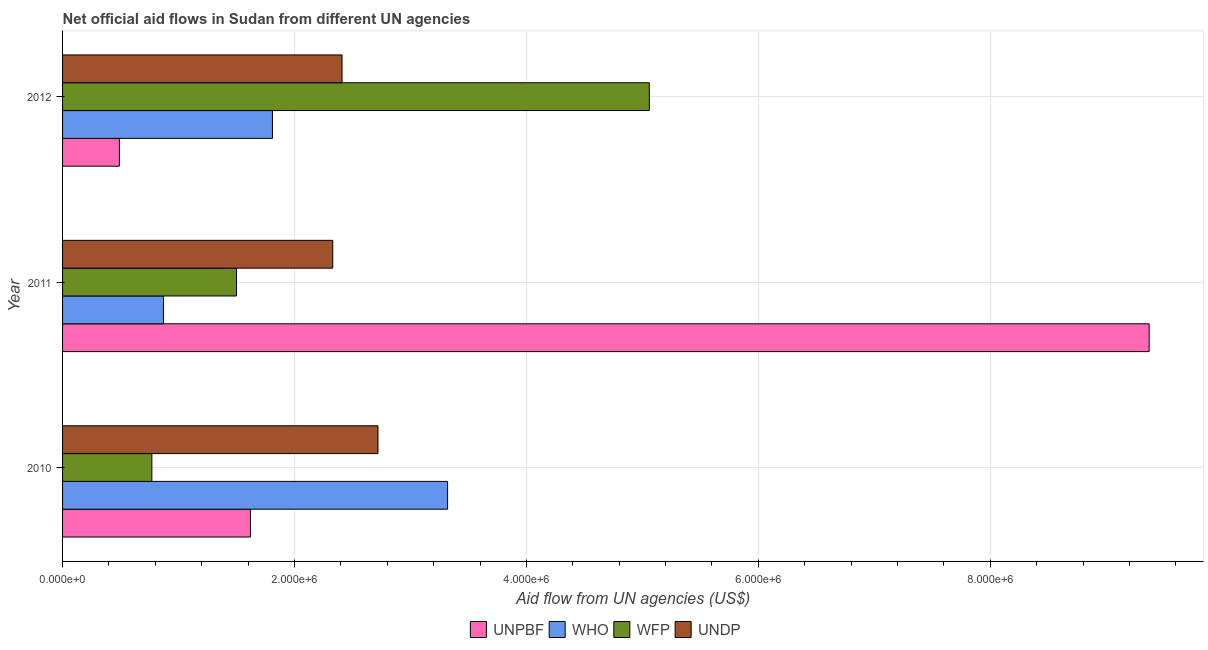How many bars are there on the 2nd tick from the top?
Offer a very short reply. 4. In how many cases, is the number of bars for a given year not equal to the number of legend labels?
Your answer should be compact. 0. What is the amount of aid given by undp in 2011?
Provide a short and direct response. 2.33e+06. Across all years, what is the maximum amount of aid given by undp?
Keep it short and to the point. 2.72e+06. Across all years, what is the minimum amount of aid given by undp?
Your answer should be compact. 2.33e+06. In which year was the amount of aid given by unpbf maximum?
Your answer should be compact. 2011. What is the total amount of aid given by who in the graph?
Ensure brevity in your answer.  6.00e+06. What is the difference between the amount of aid given by who in 2010 and that in 2011?
Offer a terse response. 2.45e+06. What is the difference between the amount of aid given by wfp in 2012 and the amount of aid given by undp in 2011?
Provide a succinct answer. 2.73e+06. What is the average amount of aid given by wfp per year?
Give a very brief answer. 2.44e+06. In the year 2010, what is the difference between the amount of aid given by who and amount of aid given by wfp?
Provide a succinct answer. 2.55e+06. What is the ratio of the amount of aid given by undp in 2010 to that in 2012?
Your answer should be compact. 1.13. What is the difference between the highest and the lowest amount of aid given by who?
Your answer should be very brief. 2.45e+06. Is the sum of the amount of aid given by undp in 2010 and 2011 greater than the maximum amount of aid given by unpbf across all years?
Ensure brevity in your answer.  No. What does the 3rd bar from the top in 2012 represents?
Make the answer very short. WHO. What does the 4th bar from the bottom in 2012 represents?
Your answer should be compact. UNDP. Is it the case that in every year, the sum of the amount of aid given by unpbf and amount of aid given by who is greater than the amount of aid given by wfp?
Your response must be concise. No. Are all the bars in the graph horizontal?
Provide a succinct answer. Yes. How many years are there in the graph?
Keep it short and to the point. 3. What is the difference between two consecutive major ticks on the X-axis?
Ensure brevity in your answer.  2.00e+06. Are the values on the major ticks of X-axis written in scientific E-notation?
Ensure brevity in your answer.  Yes. Does the graph contain any zero values?
Make the answer very short. No. Where does the legend appear in the graph?
Ensure brevity in your answer.  Bottom center. How are the legend labels stacked?
Make the answer very short. Horizontal. What is the title of the graph?
Give a very brief answer. Net official aid flows in Sudan from different UN agencies. What is the label or title of the X-axis?
Your answer should be compact. Aid flow from UN agencies (US$). What is the label or title of the Y-axis?
Provide a succinct answer. Year. What is the Aid flow from UN agencies (US$) of UNPBF in 2010?
Provide a succinct answer. 1.62e+06. What is the Aid flow from UN agencies (US$) of WHO in 2010?
Your response must be concise. 3.32e+06. What is the Aid flow from UN agencies (US$) in WFP in 2010?
Your response must be concise. 7.70e+05. What is the Aid flow from UN agencies (US$) of UNDP in 2010?
Your response must be concise. 2.72e+06. What is the Aid flow from UN agencies (US$) of UNPBF in 2011?
Provide a succinct answer. 9.37e+06. What is the Aid flow from UN agencies (US$) in WHO in 2011?
Provide a succinct answer. 8.70e+05. What is the Aid flow from UN agencies (US$) in WFP in 2011?
Make the answer very short. 1.50e+06. What is the Aid flow from UN agencies (US$) in UNDP in 2011?
Your answer should be very brief. 2.33e+06. What is the Aid flow from UN agencies (US$) in WHO in 2012?
Make the answer very short. 1.81e+06. What is the Aid flow from UN agencies (US$) in WFP in 2012?
Your answer should be very brief. 5.06e+06. What is the Aid flow from UN agencies (US$) of UNDP in 2012?
Your answer should be compact. 2.41e+06. Across all years, what is the maximum Aid flow from UN agencies (US$) of UNPBF?
Provide a short and direct response. 9.37e+06. Across all years, what is the maximum Aid flow from UN agencies (US$) of WHO?
Keep it short and to the point. 3.32e+06. Across all years, what is the maximum Aid flow from UN agencies (US$) of WFP?
Provide a short and direct response. 5.06e+06. Across all years, what is the maximum Aid flow from UN agencies (US$) in UNDP?
Offer a terse response. 2.72e+06. Across all years, what is the minimum Aid flow from UN agencies (US$) of UNPBF?
Offer a terse response. 4.90e+05. Across all years, what is the minimum Aid flow from UN agencies (US$) of WHO?
Make the answer very short. 8.70e+05. Across all years, what is the minimum Aid flow from UN agencies (US$) of WFP?
Your response must be concise. 7.70e+05. Across all years, what is the minimum Aid flow from UN agencies (US$) of UNDP?
Your answer should be very brief. 2.33e+06. What is the total Aid flow from UN agencies (US$) in UNPBF in the graph?
Your response must be concise. 1.15e+07. What is the total Aid flow from UN agencies (US$) in WHO in the graph?
Keep it short and to the point. 6.00e+06. What is the total Aid flow from UN agencies (US$) of WFP in the graph?
Offer a terse response. 7.33e+06. What is the total Aid flow from UN agencies (US$) in UNDP in the graph?
Provide a short and direct response. 7.46e+06. What is the difference between the Aid flow from UN agencies (US$) in UNPBF in 2010 and that in 2011?
Give a very brief answer. -7.75e+06. What is the difference between the Aid flow from UN agencies (US$) of WHO in 2010 and that in 2011?
Your response must be concise. 2.45e+06. What is the difference between the Aid flow from UN agencies (US$) in WFP in 2010 and that in 2011?
Ensure brevity in your answer.  -7.30e+05. What is the difference between the Aid flow from UN agencies (US$) of UNDP in 2010 and that in 2011?
Give a very brief answer. 3.90e+05. What is the difference between the Aid flow from UN agencies (US$) in UNPBF in 2010 and that in 2012?
Your response must be concise. 1.13e+06. What is the difference between the Aid flow from UN agencies (US$) in WHO in 2010 and that in 2012?
Your response must be concise. 1.51e+06. What is the difference between the Aid flow from UN agencies (US$) in WFP in 2010 and that in 2012?
Make the answer very short. -4.29e+06. What is the difference between the Aid flow from UN agencies (US$) in UNPBF in 2011 and that in 2012?
Your answer should be compact. 8.88e+06. What is the difference between the Aid flow from UN agencies (US$) of WHO in 2011 and that in 2012?
Make the answer very short. -9.40e+05. What is the difference between the Aid flow from UN agencies (US$) of WFP in 2011 and that in 2012?
Your answer should be compact. -3.56e+06. What is the difference between the Aid flow from UN agencies (US$) in UNDP in 2011 and that in 2012?
Provide a short and direct response. -8.00e+04. What is the difference between the Aid flow from UN agencies (US$) of UNPBF in 2010 and the Aid flow from UN agencies (US$) of WHO in 2011?
Offer a terse response. 7.50e+05. What is the difference between the Aid flow from UN agencies (US$) in UNPBF in 2010 and the Aid flow from UN agencies (US$) in UNDP in 2011?
Give a very brief answer. -7.10e+05. What is the difference between the Aid flow from UN agencies (US$) of WHO in 2010 and the Aid flow from UN agencies (US$) of WFP in 2011?
Make the answer very short. 1.82e+06. What is the difference between the Aid flow from UN agencies (US$) of WHO in 2010 and the Aid flow from UN agencies (US$) of UNDP in 2011?
Make the answer very short. 9.90e+05. What is the difference between the Aid flow from UN agencies (US$) in WFP in 2010 and the Aid flow from UN agencies (US$) in UNDP in 2011?
Your answer should be compact. -1.56e+06. What is the difference between the Aid flow from UN agencies (US$) in UNPBF in 2010 and the Aid flow from UN agencies (US$) in WFP in 2012?
Offer a terse response. -3.44e+06. What is the difference between the Aid flow from UN agencies (US$) in UNPBF in 2010 and the Aid flow from UN agencies (US$) in UNDP in 2012?
Your answer should be very brief. -7.90e+05. What is the difference between the Aid flow from UN agencies (US$) in WHO in 2010 and the Aid flow from UN agencies (US$) in WFP in 2012?
Your response must be concise. -1.74e+06. What is the difference between the Aid flow from UN agencies (US$) in WHO in 2010 and the Aid flow from UN agencies (US$) in UNDP in 2012?
Your response must be concise. 9.10e+05. What is the difference between the Aid flow from UN agencies (US$) in WFP in 2010 and the Aid flow from UN agencies (US$) in UNDP in 2012?
Ensure brevity in your answer.  -1.64e+06. What is the difference between the Aid flow from UN agencies (US$) in UNPBF in 2011 and the Aid flow from UN agencies (US$) in WHO in 2012?
Your answer should be compact. 7.56e+06. What is the difference between the Aid flow from UN agencies (US$) of UNPBF in 2011 and the Aid flow from UN agencies (US$) of WFP in 2012?
Provide a short and direct response. 4.31e+06. What is the difference between the Aid flow from UN agencies (US$) of UNPBF in 2011 and the Aid flow from UN agencies (US$) of UNDP in 2012?
Provide a succinct answer. 6.96e+06. What is the difference between the Aid flow from UN agencies (US$) of WHO in 2011 and the Aid flow from UN agencies (US$) of WFP in 2012?
Keep it short and to the point. -4.19e+06. What is the difference between the Aid flow from UN agencies (US$) of WHO in 2011 and the Aid flow from UN agencies (US$) of UNDP in 2012?
Your answer should be very brief. -1.54e+06. What is the difference between the Aid flow from UN agencies (US$) in WFP in 2011 and the Aid flow from UN agencies (US$) in UNDP in 2012?
Offer a very short reply. -9.10e+05. What is the average Aid flow from UN agencies (US$) in UNPBF per year?
Provide a succinct answer. 3.83e+06. What is the average Aid flow from UN agencies (US$) of WFP per year?
Make the answer very short. 2.44e+06. What is the average Aid flow from UN agencies (US$) in UNDP per year?
Your answer should be very brief. 2.49e+06. In the year 2010, what is the difference between the Aid flow from UN agencies (US$) in UNPBF and Aid flow from UN agencies (US$) in WHO?
Give a very brief answer. -1.70e+06. In the year 2010, what is the difference between the Aid flow from UN agencies (US$) in UNPBF and Aid flow from UN agencies (US$) in WFP?
Your answer should be compact. 8.50e+05. In the year 2010, what is the difference between the Aid flow from UN agencies (US$) of UNPBF and Aid flow from UN agencies (US$) of UNDP?
Give a very brief answer. -1.10e+06. In the year 2010, what is the difference between the Aid flow from UN agencies (US$) of WHO and Aid flow from UN agencies (US$) of WFP?
Ensure brevity in your answer.  2.55e+06. In the year 2010, what is the difference between the Aid flow from UN agencies (US$) in WFP and Aid flow from UN agencies (US$) in UNDP?
Give a very brief answer. -1.95e+06. In the year 2011, what is the difference between the Aid flow from UN agencies (US$) in UNPBF and Aid flow from UN agencies (US$) in WHO?
Give a very brief answer. 8.50e+06. In the year 2011, what is the difference between the Aid flow from UN agencies (US$) in UNPBF and Aid flow from UN agencies (US$) in WFP?
Provide a succinct answer. 7.87e+06. In the year 2011, what is the difference between the Aid flow from UN agencies (US$) in UNPBF and Aid flow from UN agencies (US$) in UNDP?
Offer a terse response. 7.04e+06. In the year 2011, what is the difference between the Aid flow from UN agencies (US$) in WHO and Aid flow from UN agencies (US$) in WFP?
Offer a terse response. -6.30e+05. In the year 2011, what is the difference between the Aid flow from UN agencies (US$) in WHO and Aid flow from UN agencies (US$) in UNDP?
Keep it short and to the point. -1.46e+06. In the year 2011, what is the difference between the Aid flow from UN agencies (US$) in WFP and Aid flow from UN agencies (US$) in UNDP?
Your response must be concise. -8.30e+05. In the year 2012, what is the difference between the Aid flow from UN agencies (US$) in UNPBF and Aid flow from UN agencies (US$) in WHO?
Offer a very short reply. -1.32e+06. In the year 2012, what is the difference between the Aid flow from UN agencies (US$) in UNPBF and Aid flow from UN agencies (US$) in WFP?
Offer a very short reply. -4.57e+06. In the year 2012, what is the difference between the Aid flow from UN agencies (US$) of UNPBF and Aid flow from UN agencies (US$) of UNDP?
Give a very brief answer. -1.92e+06. In the year 2012, what is the difference between the Aid flow from UN agencies (US$) of WHO and Aid flow from UN agencies (US$) of WFP?
Ensure brevity in your answer.  -3.25e+06. In the year 2012, what is the difference between the Aid flow from UN agencies (US$) of WHO and Aid flow from UN agencies (US$) of UNDP?
Give a very brief answer. -6.00e+05. In the year 2012, what is the difference between the Aid flow from UN agencies (US$) of WFP and Aid flow from UN agencies (US$) of UNDP?
Your answer should be very brief. 2.65e+06. What is the ratio of the Aid flow from UN agencies (US$) in UNPBF in 2010 to that in 2011?
Offer a very short reply. 0.17. What is the ratio of the Aid flow from UN agencies (US$) in WHO in 2010 to that in 2011?
Your answer should be very brief. 3.82. What is the ratio of the Aid flow from UN agencies (US$) of WFP in 2010 to that in 2011?
Provide a short and direct response. 0.51. What is the ratio of the Aid flow from UN agencies (US$) in UNDP in 2010 to that in 2011?
Offer a very short reply. 1.17. What is the ratio of the Aid flow from UN agencies (US$) of UNPBF in 2010 to that in 2012?
Offer a terse response. 3.31. What is the ratio of the Aid flow from UN agencies (US$) in WHO in 2010 to that in 2012?
Provide a succinct answer. 1.83. What is the ratio of the Aid flow from UN agencies (US$) in WFP in 2010 to that in 2012?
Make the answer very short. 0.15. What is the ratio of the Aid flow from UN agencies (US$) in UNDP in 2010 to that in 2012?
Your response must be concise. 1.13. What is the ratio of the Aid flow from UN agencies (US$) in UNPBF in 2011 to that in 2012?
Provide a succinct answer. 19.12. What is the ratio of the Aid flow from UN agencies (US$) of WHO in 2011 to that in 2012?
Your answer should be compact. 0.48. What is the ratio of the Aid flow from UN agencies (US$) of WFP in 2011 to that in 2012?
Offer a terse response. 0.3. What is the ratio of the Aid flow from UN agencies (US$) of UNDP in 2011 to that in 2012?
Offer a terse response. 0.97. What is the difference between the highest and the second highest Aid flow from UN agencies (US$) in UNPBF?
Offer a very short reply. 7.75e+06. What is the difference between the highest and the second highest Aid flow from UN agencies (US$) in WHO?
Offer a very short reply. 1.51e+06. What is the difference between the highest and the second highest Aid flow from UN agencies (US$) of WFP?
Keep it short and to the point. 3.56e+06. What is the difference between the highest and the lowest Aid flow from UN agencies (US$) in UNPBF?
Make the answer very short. 8.88e+06. What is the difference between the highest and the lowest Aid flow from UN agencies (US$) in WHO?
Provide a succinct answer. 2.45e+06. What is the difference between the highest and the lowest Aid flow from UN agencies (US$) of WFP?
Offer a very short reply. 4.29e+06. What is the difference between the highest and the lowest Aid flow from UN agencies (US$) of UNDP?
Provide a short and direct response. 3.90e+05. 